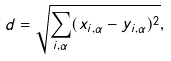Convert formula to latex. <formula><loc_0><loc_0><loc_500><loc_500>d = \sqrt { \sum _ { i , \alpha } ( x _ { i , \alpha } - y _ { i , \alpha } ) ^ { 2 } } ,</formula> 